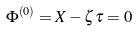Convert formula to latex. <formula><loc_0><loc_0><loc_500><loc_500>\Phi ^ { \left ( 0 \right ) } = X - \zeta \tau = 0</formula> 